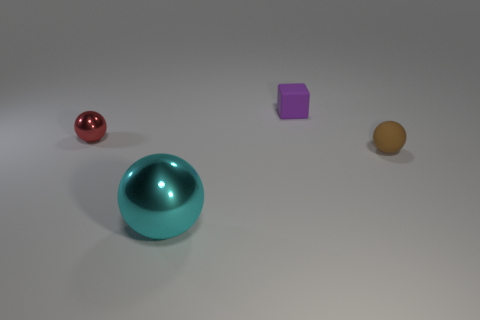Are there any other tiny green blocks made of the same material as the tiny block?
Your answer should be very brief. No. There is a big cyan shiny thing that is left of the tiny sphere that is to the right of the purple thing; are there any purple blocks right of it?
Your response must be concise. Yes. What is the shape of the purple object that is the same size as the brown ball?
Give a very brief answer. Cube. Is the size of the sphere that is right of the tiny purple block the same as the red ball that is in front of the purple rubber object?
Make the answer very short. Yes. What number of small matte things are there?
Your answer should be compact. 2. There is a matte object in front of the small object that is left of the purple matte cube to the left of the small rubber ball; what size is it?
Provide a short and direct response. Small. Is there any other thing that has the same size as the cyan thing?
Make the answer very short. No. How many brown things are left of the small purple cube?
Ensure brevity in your answer.  0. Are there the same number of shiny spheres behind the big cyan metal object and yellow matte things?
Offer a terse response. No. How many things are either cyan rubber balls or small brown matte objects?
Give a very brief answer. 1. 